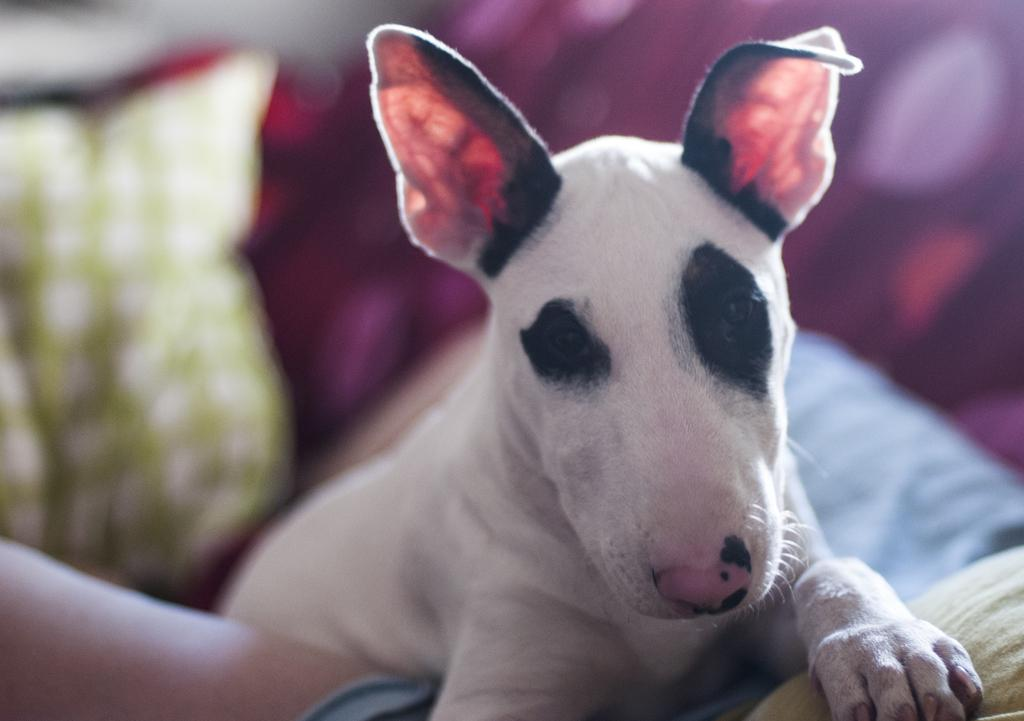What type of animal is in the image? There is a dog in the image. Where is the dog located in the image? The dog is on a person's body. What else can be seen in the image besides the dog? There are pillows visible in the image. What type of spot can be seen on the dog's fur in the image? There is no specific spot mentioned in the facts, and therefore no such detail can be observed. What type of band is playing music in the image? There is no band present in the image. 